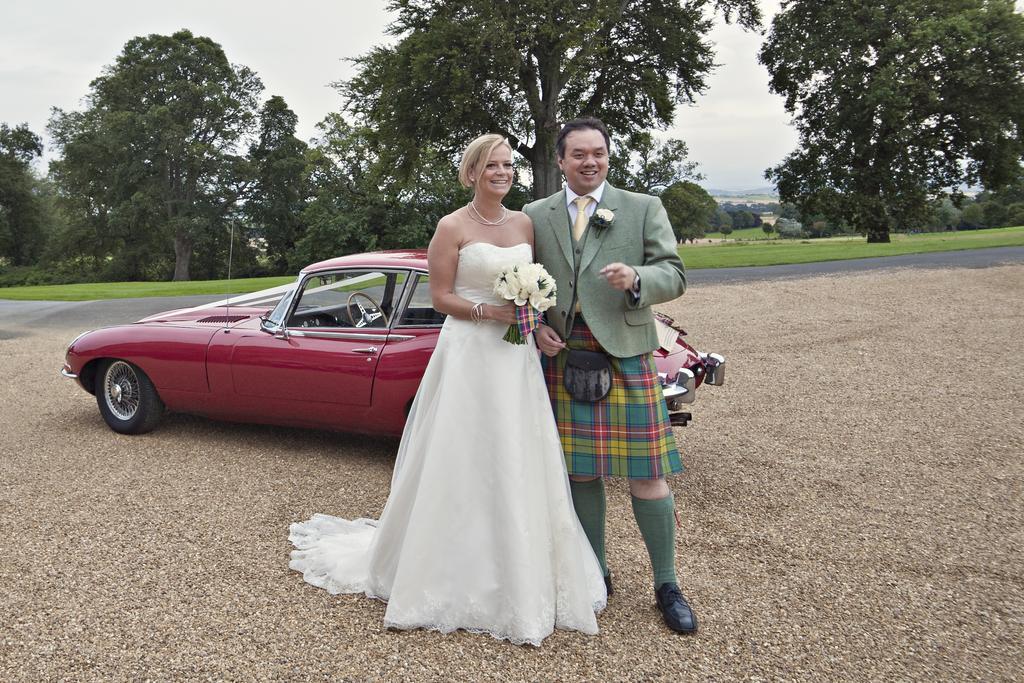Could you give a brief overview of what you see in this image? This picture is clicked outside. On the right we can see a person wearing suit, smiling and standing and we can see a woman wearing white color gown, holding a bouquet and standing and we can see a red color car parked on the ground. In the background we can see the sky, trees, plants and green grass and some other objects. 